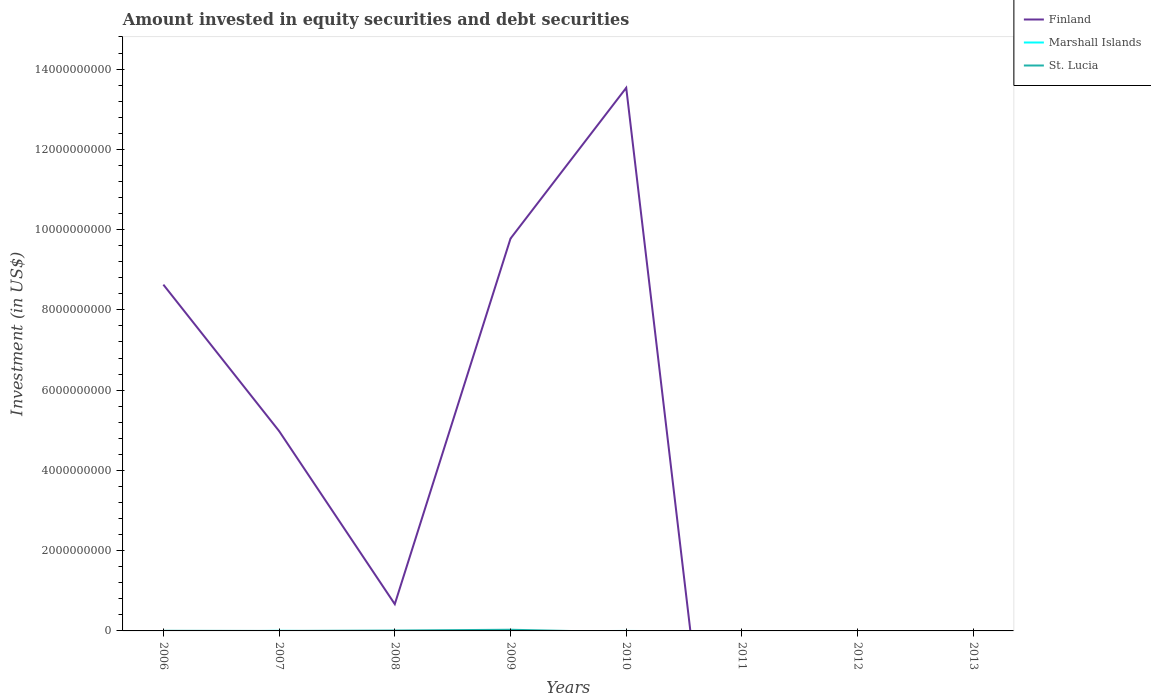Does the line corresponding to Finland intersect with the line corresponding to Marshall Islands?
Ensure brevity in your answer.  Yes. What is the total amount invested in equity securities and debt securities in Finland in the graph?
Make the answer very short. -3.76e+09. What is the difference between the highest and the second highest amount invested in equity securities and debt securities in Finland?
Offer a very short reply. 1.35e+1. What is the difference between the highest and the lowest amount invested in equity securities and debt securities in St. Lucia?
Give a very brief answer. 2. What is the difference between two consecutive major ticks on the Y-axis?
Give a very brief answer. 2.00e+09. Does the graph contain any zero values?
Provide a succinct answer. Yes. Where does the legend appear in the graph?
Provide a succinct answer. Top right. What is the title of the graph?
Provide a short and direct response. Amount invested in equity securities and debt securities. What is the label or title of the Y-axis?
Provide a short and direct response. Investment (in US$). What is the Investment (in US$) in Finland in 2006?
Your response must be concise. 8.63e+09. What is the Investment (in US$) in Marshall Islands in 2006?
Your response must be concise. 0. What is the Investment (in US$) of St. Lucia in 2006?
Give a very brief answer. 2.96e+06. What is the Investment (in US$) in Finland in 2007?
Provide a succinct answer. 4.98e+09. What is the Investment (in US$) of Marshall Islands in 2007?
Provide a succinct answer. 1.97e+06. What is the Investment (in US$) in St. Lucia in 2007?
Your answer should be compact. 0. What is the Investment (in US$) in Finland in 2008?
Offer a very short reply. 6.68e+08. What is the Investment (in US$) in St. Lucia in 2008?
Provide a short and direct response. 9.56e+06. What is the Investment (in US$) in Finland in 2009?
Provide a short and direct response. 9.78e+09. What is the Investment (in US$) in Marshall Islands in 2009?
Offer a terse response. 0. What is the Investment (in US$) in St. Lucia in 2009?
Your answer should be very brief. 2.91e+07. What is the Investment (in US$) of Finland in 2010?
Give a very brief answer. 1.35e+1. What is the Investment (in US$) in St. Lucia in 2010?
Your answer should be very brief. 0. What is the Investment (in US$) in St. Lucia in 2011?
Offer a terse response. 0. What is the Investment (in US$) of Finland in 2012?
Offer a very short reply. 0. What is the Investment (in US$) in Marshall Islands in 2013?
Provide a succinct answer. 0. What is the Investment (in US$) of St. Lucia in 2013?
Your answer should be very brief. 0. Across all years, what is the maximum Investment (in US$) in Finland?
Your answer should be compact. 1.35e+1. Across all years, what is the maximum Investment (in US$) of Marshall Islands?
Provide a succinct answer. 1.97e+06. Across all years, what is the maximum Investment (in US$) of St. Lucia?
Offer a very short reply. 2.91e+07. Across all years, what is the minimum Investment (in US$) of Marshall Islands?
Provide a succinct answer. 0. Across all years, what is the minimum Investment (in US$) of St. Lucia?
Offer a terse response. 0. What is the total Investment (in US$) of Finland in the graph?
Give a very brief answer. 3.76e+1. What is the total Investment (in US$) of Marshall Islands in the graph?
Your response must be concise. 1.97e+06. What is the total Investment (in US$) of St. Lucia in the graph?
Your answer should be very brief. 4.17e+07. What is the difference between the Investment (in US$) in Finland in 2006 and that in 2007?
Your response must be concise. 3.65e+09. What is the difference between the Investment (in US$) of Finland in 2006 and that in 2008?
Offer a terse response. 7.96e+09. What is the difference between the Investment (in US$) of St. Lucia in 2006 and that in 2008?
Offer a terse response. -6.60e+06. What is the difference between the Investment (in US$) in Finland in 2006 and that in 2009?
Make the answer very short. -1.15e+09. What is the difference between the Investment (in US$) in St. Lucia in 2006 and that in 2009?
Ensure brevity in your answer.  -2.62e+07. What is the difference between the Investment (in US$) in Finland in 2006 and that in 2010?
Ensure brevity in your answer.  -4.90e+09. What is the difference between the Investment (in US$) in Finland in 2007 and that in 2008?
Ensure brevity in your answer.  4.31e+09. What is the difference between the Investment (in US$) of Finland in 2007 and that in 2009?
Your answer should be very brief. -4.80e+09. What is the difference between the Investment (in US$) in Finland in 2007 and that in 2010?
Give a very brief answer. -8.55e+09. What is the difference between the Investment (in US$) in Finland in 2008 and that in 2009?
Offer a very short reply. -9.11e+09. What is the difference between the Investment (in US$) of St. Lucia in 2008 and that in 2009?
Ensure brevity in your answer.  -1.96e+07. What is the difference between the Investment (in US$) of Finland in 2008 and that in 2010?
Ensure brevity in your answer.  -1.29e+1. What is the difference between the Investment (in US$) of Finland in 2009 and that in 2010?
Offer a very short reply. -3.76e+09. What is the difference between the Investment (in US$) of Finland in 2006 and the Investment (in US$) of Marshall Islands in 2007?
Offer a very short reply. 8.63e+09. What is the difference between the Investment (in US$) of Finland in 2006 and the Investment (in US$) of St. Lucia in 2008?
Your answer should be compact. 8.62e+09. What is the difference between the Investment (in US$) in Finland in 2006 and the Investment (in US$) in St. Lucia in 2009?
Ensure brevity in your answer.  8.60e+09. What is the difference between the Investment (in US$) in Finland in 2007 and the Investment (in US$) in St. Lucia in 2008?
Make the answer very short. 4.97e+09. What is the difference between the Investment (in US$) in Marshall Islands in 2007 and the Investment (in US$) in St. Lucia in 2008?
Offer a very short reply. -7.59e+06. What is the difference between the Investment (in US$) of Finland in 2007 and the Investment (in US$) of St. Lucia in 2009?
Give a very brief answer. 4.95e+09. What is the difference between the Investment (in US$) in Marshall Islands in 2007 and the Investment (in US$) in St. Lucia in 2009?
Keep it short and to the point. -2.72e+07. What is the difference between the Investment (in US$) of Finland in 2008 and the Investment (in US$) of St. Lucia in 2009?
Offer a very short reply. 6.39e+08. What is the average Investment (in US$) in Finland per year?
Your answer should be very brief. 4.70e+09. What is the average Investment (in US$) of Marshall Islands per year?
Your answer should be compact. 2.46e+05. What is the average Investment (in US$) in St. Lucia per year?
Your answer should be compact. 5.21e+06. In the year 2006, what is the difference between the Investment (in US$) in Finland and Investment (in US$) in St. Lucia?
Provide a short and direct response. 8.63e+09. In the year 2007, what is the difference between the Investment (in US$) in Finland and Investment (in US$) in Marshall Islands?
Keep it short and to the point. 4.98e+09. In the year 2008, what is the difference between the Investment (in US$) of Finland and Investment (in US$) of St. Lucia?
Your answer should be compact. 6.59e+08. In the year 2009, what is the difference between the Investment (in US$) in Finland and Investment (in US$) in St. Lucia?
Provide a short and direct response. 9.75e+09. What is the ratio of the Investment (in US$) of Finland in 2006 to that in 2007?
Give a very brief answer. 1.73. What is the ratio of the Investment (in US$) in Finland in 2006 to that in 2008?
Ensure brevity in your answer.  12.92. What is the ratio of the Investment (in US$) in St. Lucia in 2006 to that in 2008?
Your response must be concise. 0.31. What is the ratio of the Investment (in US$) of Finland in 2006 to that in 2009?
Your response must be concise. 0.88. What is the ratio of the Investment (in US$) of St. Lucia in 2006 to that in 2009?
Make the answer very short. 0.1. What is the ratio of the Investment (in US$) in Finland in 2006 to that in 2010?
Your response must be concise. 0.64. What is the ratio of the Investment (in US$) of Finland in 2007 to that in 2008?
Give a very brief answer. 7.46. What is the ratio of the Investment (in US$) in Finland in 2007 to that in 2009?
Provide a succinct answer. 0.51. What is the ratio of the Investment (in US$) of Finland in 2007 to that in 2010?
Your response must be concise. 0.37. What is the ratio of the Investment (in US$) in Finland in 2008 to that in 2009?
Your answer should be compact. 0.07. What is the ratio of the Investment (in US$) in St. Lucia in 2008 to that in 2009?
Ensure brevity in your answer.  0.33. What is the ratio of the Investment (in US$) in Finland in 2008 to that in 2010?
Keep it short and to the point. 0.05. What is the ratio of the Investment (in US$) in Finland in 2009 to that in 2010?
Offer a very short reply. 0.72. What is the difference between the highest and the second highest Investment (in US$) in Finland?
Make the answer very short. 3.76e+09. What is the difference between the highest and the second highest Investment (in US$) in St. Lucia?
Your response must be concise. 1.96e+07. What is the difference between the highest and the lowest Investment (in US$) in Finland?
Your response must be concise. 1.35e+1. What is the difference between the highest and the lowest Investment (in US$) in Marshall Islands?
Keep it short and to the point. 1.97e+06. What is the difference between the highest and the lowest Investment (in US$) of St. Lucia?
Your answer should be very brief. 2.91e+07. 